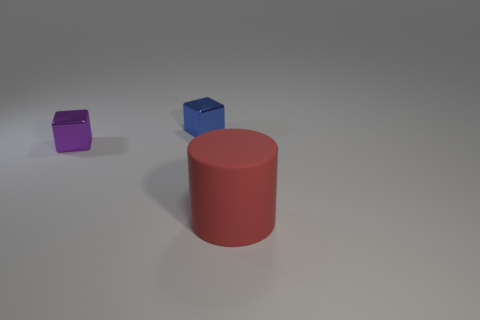What might be the purpose of this arrangement of objects? The arrangement might be part of a visual study, perhaps for exploring geometric forms, color theory, or the interplay of light and shadow in 3D rendering or photography. It provides a simple yet effective composition for examining these elements. 